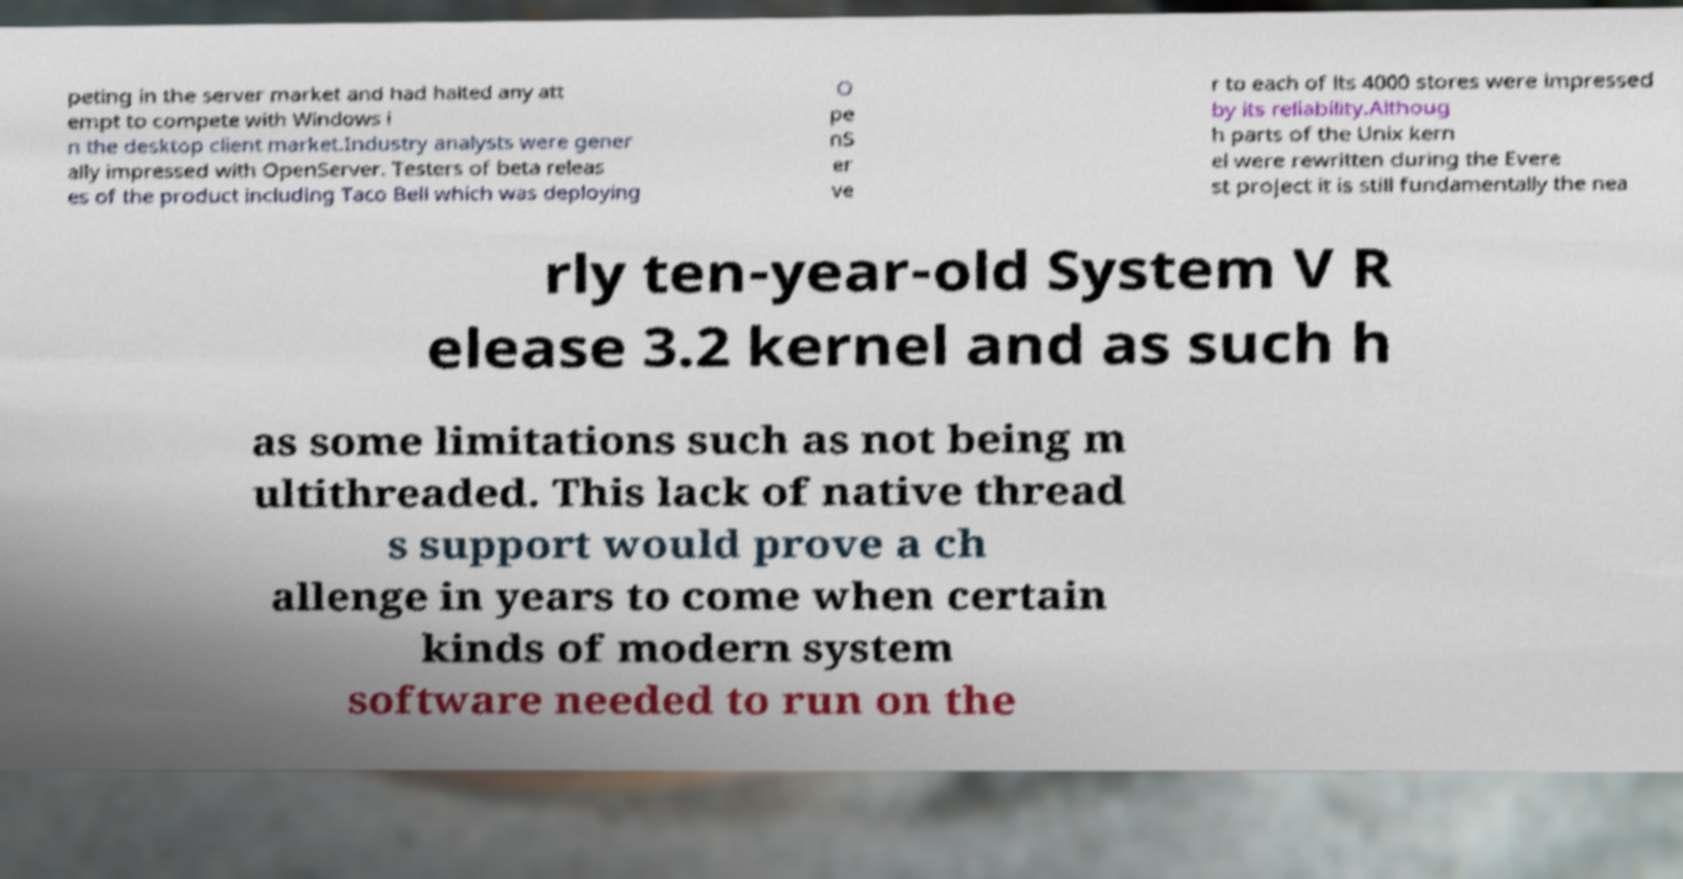What messages or text are displayed in this image? I need them in a readable, typed format. peting in the server market and had halted any att empt to compete with Windows i n the desktop client market.Industry analysts were gener ally impressed with OpenServer. Testers of beta releas es of the product including Taco Bell which was deploying O pe nS er ve r to each of its 4000 stores were impressed by its reliability.Althoug h parts of the Unix kern el were rewritten during the Evere st project it is still fundamentally the nea rly ten-year-old System V R elease 3.2 kernel and as such h as some limitations such as not being m ultithreaded. This lack of native thread s support would prove a ch allenge in years to come when certain kinds of modern system software needed to run on the 